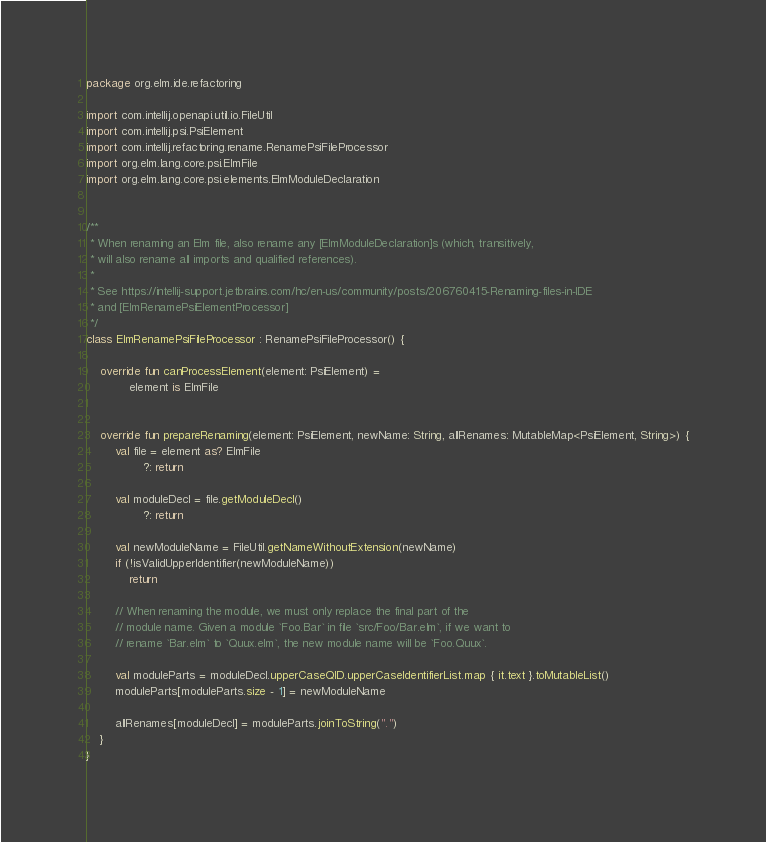Convert code to text. <code><loc_0><loc_0><loc_500><loc_500><_Kotlin_>package org.elm.ide.refactoring

import com.intellij.openapi.util.io.FileUtil
import com.intellij.psi.PsiElement
import com.intellij.refactoring.rename.RenamePsiFileProcessor
import org.elm.lang.core.psi.ElmFile
import org.elm.lang.core.psi.elements.ElmModuleDeclaration


/**
 * When renaming an Elm file, also rename any [ElmModuleDeclaration]s (which, transitively,
 * will also rename all imports and qualified references).
 *
 * See https://intellij-support.jetbrains.com/hc/en-us/community/posts/206760415-Renaming-files-in-IDE
 * and [ElmRenamePsiElementProcessor]
 */
class ElmRenamePsiFileProcessor : RenamePsiFileProcessor() {

    override fun canProcessElement(element: PsiElement) =
            element is ElmFile


    override fun prepareRenaming(element: PsiElement, newName: String, allRenames: MutableMap<PsiElement, String>) {
        val file = element as? ElmFile
                ?: return

        val moduleDecl = file.getModuleDecl()
                ?: return

        val newModuleName = FileUtil.getNameWithoutExtension(newName)
        if (!isValidUpperIdentifier(newModuleName))
            return

        // When renaming the module, we must only replace the final part of the
        // module name. Given a module `Foo.Bar` in file `src/Foo/Bar.elm`, if we want to
        // rename `Bar.elm` to `Quux.elm`, the new module name will be `Foo.Quux`.

        val moduleParts = moduleDecl.upperCaseQID.upperCaseIdentifierList.map { it.text }.toMutableList()
        moduleParts[moduleParts.size - 1] = newModuleName

        allRenames[moduleDecl] = moduleParts.joinToString(".")
    }
}</code> 